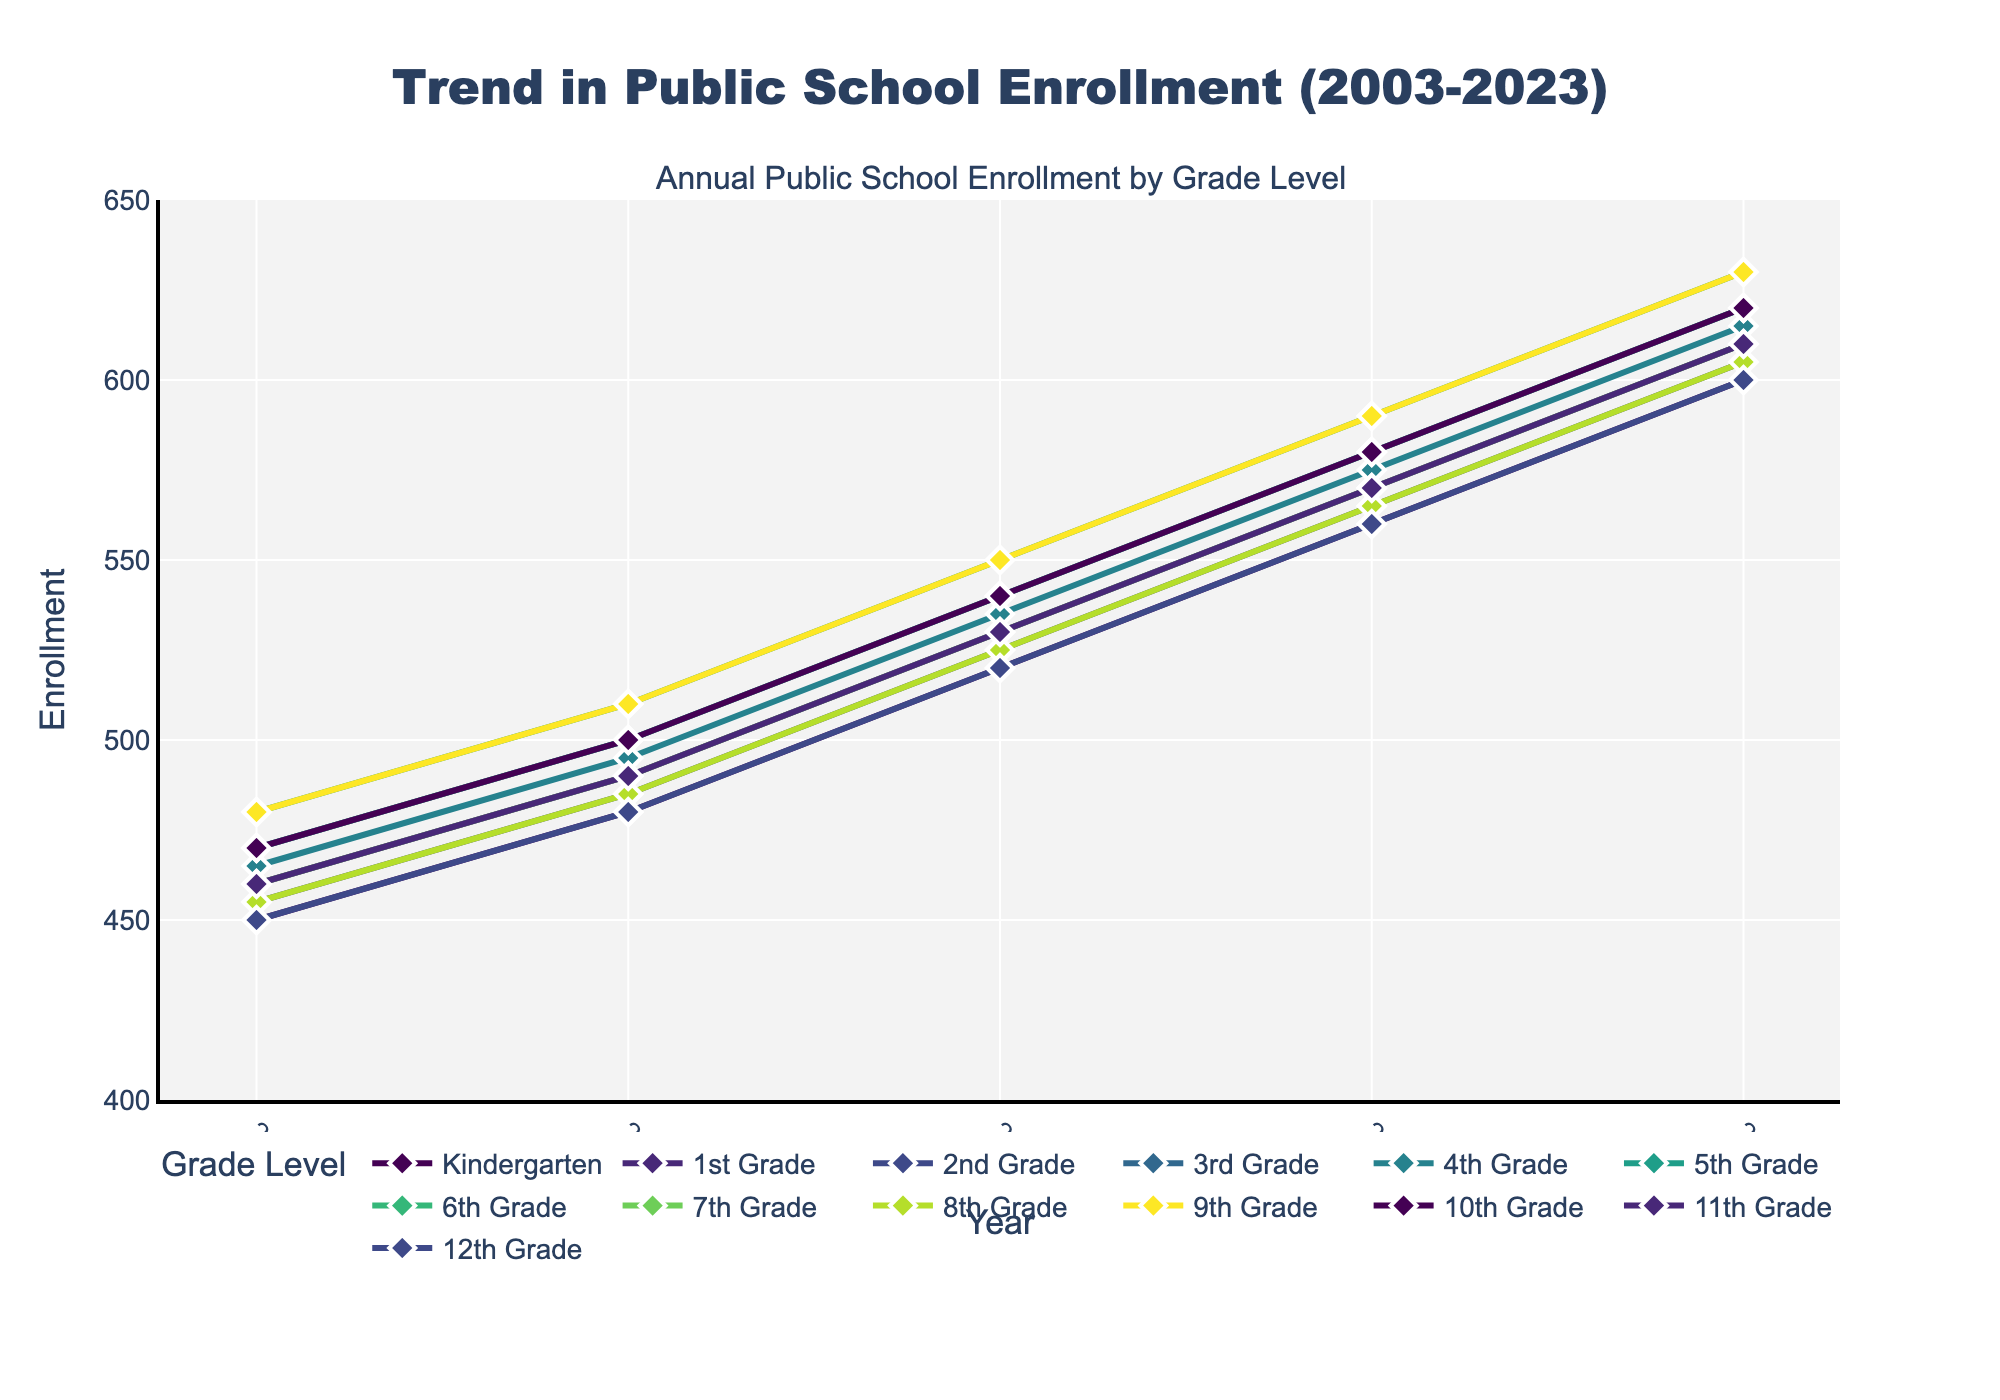What is the title of the plot? The title of the plot is located at the top and is clearly shown in the figure.
Answer: Trend in Public School Enrollment (2003-2023) What are the x-axis and y-axis labels of the plot? The labels of the axes are usually located beside them; the x-axis label is at the bottom, and the y-axis label is on the left side.
Answer: x-axis: Year, y-axis: Enrollment Which grade has the highest enrollment in 2023? By looking at the endpoint of each grade's line in 2023, we can determine that the grade with the highest enrollment is the one with the highest value.
Answer: 5th Grade How has the enrollment for Kindergarten changed from 2003 to 2023? By observing the line corresponding to Kindergarten from 2003 to 2023, we can see whether the trend is increasing, decreasing, or remaining stable overall.
Answer: Increased Which grade level shows the most growth in enrollment from 2003 to 2023? Find the difference in enrollment numbers for each grade between 2003 and 2023, then identify the one with the highest growth.
Answer: 5th Grade What is the average enrollment for 3rd Grade over the 20-year period? Sum the enrollment numbers for 3rd Grade across all the years and then divide by the number of data points (5).
Answer: (470 + 500 + 540 + 580 + 620) / 5 = 542 Which year had the highest overall enrollment across all grades? Sum the enrollment numbers for each year and compare them to find the year with the highest total enrollment.
Answer: 2023 How does the enrollment trend for 9th Grade compare to that of 12th Grade over the 20 years? Compare the lines for 9th and 12th Grades by looking at their trends over time to see if one is increasing faster, decreasing, or if they follow a similar pattern.
Answer: 9th Grade shows a consistently higher trend compared to 12th Grade What is the median enrollment value for 7th Grade? Organize the enrollment numbers for 7th Grade in ascending order and find the middle value.
Answer: (460 + 490 + 530 + 570 + 610) = 530 